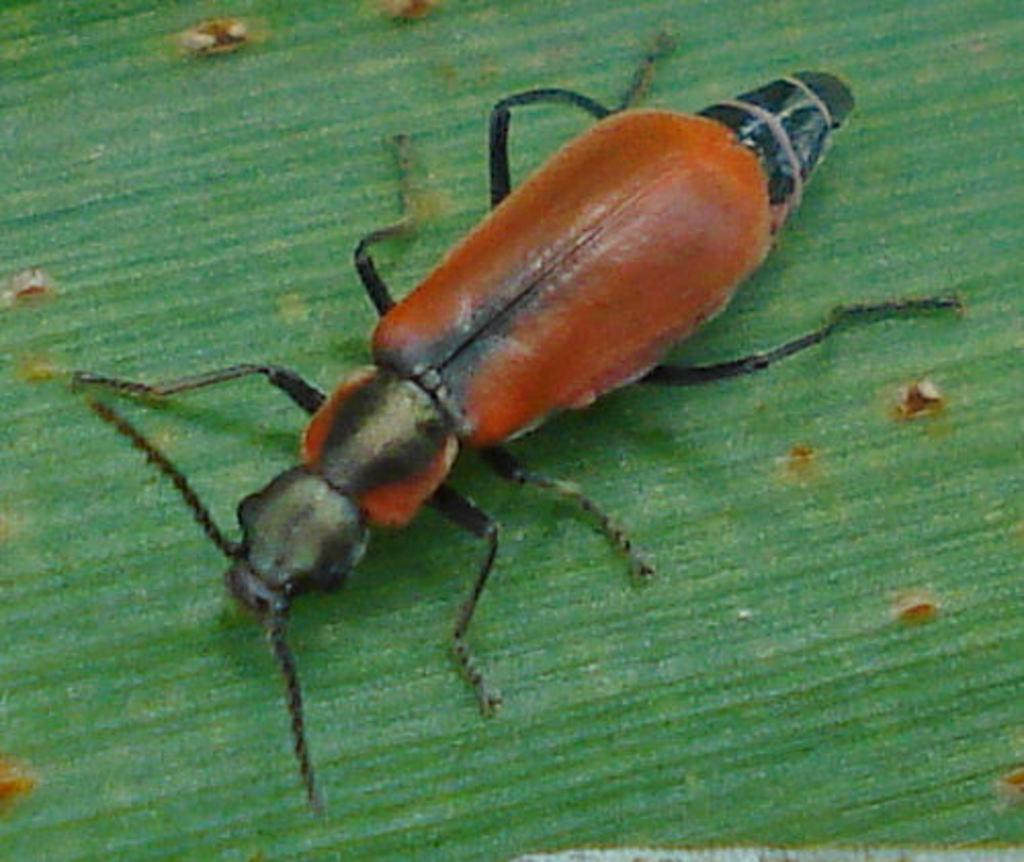What type of creature is present in the image? There is an insect in the image. Where is the insect located in the image? The insect is on the floor. What disease does the insect's partner have in the image? There is no indication of a partner or disease in the image, as it only features an insect on the floor. 